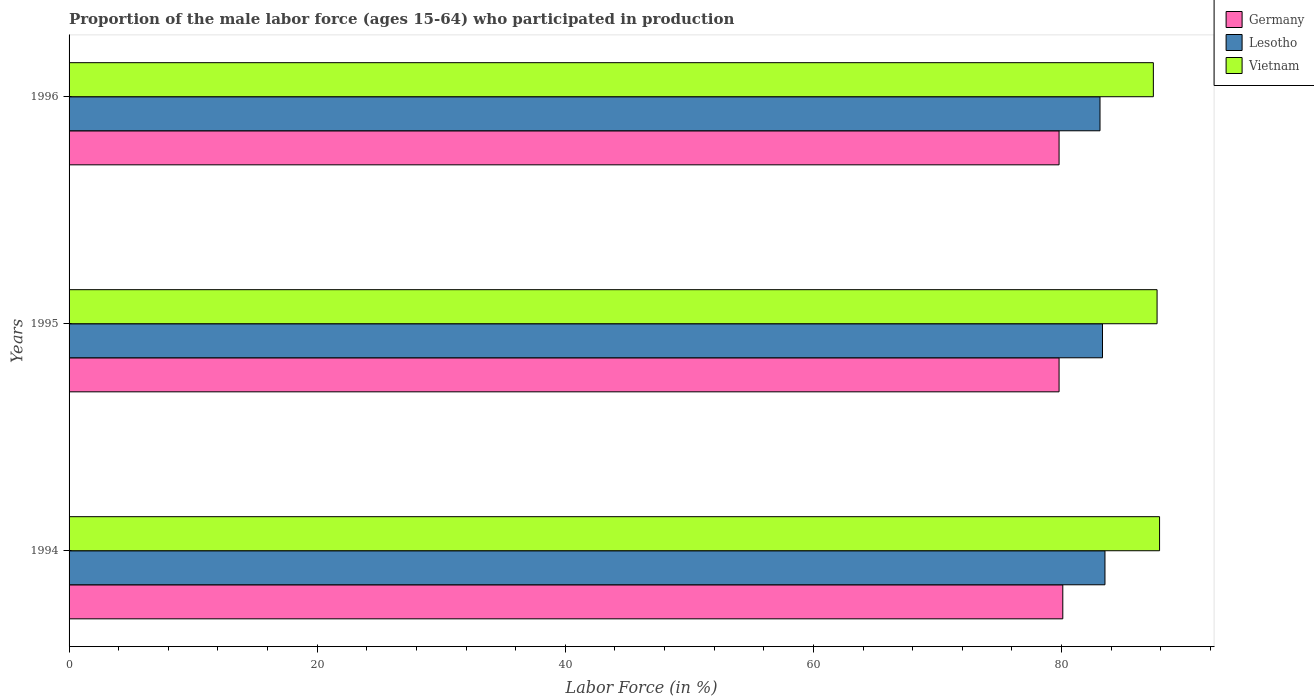How many different coloured bars are there?
Provide a succinct answer. 3. Are the number of bars per tick equal to the number of legend labels?
Provide a short and direct response. Yes. Are the number of bars on each tick of the Y-axis equal?
Ensure brevity in your answer.  Yes. How many bars are there on the 3rd tick from the top?
Your response must be concise. 3. How many bars are there on the 1st tick from the bottom?
Your answer should be very brief. 3. What is the label of the 3rd group of bars from the top?
Offer a terse response. 1994. What is the proportion of the male labor force who participated in production in Lesotho in 1994?
Give a very brief answer. 83.5. Across all years, what is the maximum proportion of the male labor force who participated in production in Vietnam?
Give a very brief answer. 87.9. Across all years, what is the minimum proportion of the male labor force who participated in production in Vietnam?
Provide a short and direct response. 87.4. In which year was the proportion of the male labor force who participated in production in Germany maximum?
Ensure brevity in your answer.  1994. In which year was the proportion of the male labor force who participated in production in Germany minimum?
Offer a terse response. 1995. What is the total proportion of the male labor force who participated in production in Germany in the graph?
Ensure brevity in your answer.  239.7. What is the difference between the proportion of the male labor force who participated in production in Vietnam in 1994 and that in 1995?
Your answer should be compact. 0.2. What is the difference between the proportion of the male labor force who participated in production in Germany in 1994 and the proportion of the male labor force who participated in production in Vietnam in 1995?
Offer a very short reply. -7.6. What is the average proportion of the male labor force who participated in production in Germany per year?
Ensure brevity in your answer.  79.9. In the year 1995, what is the difference between the proportion of the male labor force who participated in production in Germany and proportion of the male labor force who participated in production in Vietnam?
Offer a terse response. -7.9. In how many years, is the proportion of the male labor force who participated in production in Germany greater than 16 %?
Offer a terse response. 3. What is the ratio of the proportion of the male labor force who participated in production in Vietnam in 1994 to that in 1996?
Provide a short and direct response. 1.01. Is the proportion of the male labor force who participated in production in Vietnam in 1995 less than that in 1996?
Your answer should be very brief. No. Is the difference between the proportion of the male labor force who participated in production in Germany in 1995 and 1996 greater than the difference between the proportion of the male labor force who participated in production in Vietnam in 1995 and 1996?
Provide a succinct answer. No. What is the difference between the highest and the second highest proportion of the male labor force who participated in production in Germany?
Your answer should be compact. 0.3. What is the difference between the highest and the lowest proportion of the male labor force who participated in production in Lesotho?
Your answer should be very brief. 0.4. What does the 1st bar from the top in 1995 represents?
Keep it short and to the point. Vietnam. What does the 1st bar from the bottom in 1996 represents?
Provide a succinct answer. Germany. Are all the bars in the graph horizontal?
Give a very brief answer. Yes. Where does the legend appear in the graph?
Keep it short and to the point. Top right. What is the title of the graph?
Ensure brevity in your answer.  Proportion of the male labor force (ages 15-64) who participated in production. Does "Arab World" appear as one of the legend labels in the graph?
Keep it short and to the point. No. What is the label or title of the Y-axis?
Make the answer very short. Years. What is the Labor Force (in %) of Germany in 1994?
Offer a very short reply. 80.1. What is the Labor Force (in %) in Lesotho in 1994?
Your response must be concise. 83.5. What is the Labor Force (in %) in Vietnam in 1994?
Give a very brief answer. 87.9. What is the Labor Force (in %) in Germany in 1995?
Your answer should be compact. 79.8. What is the Labor Force (in %) in Lesotho in 1995?
Your answer should be very brief. 83.3. What is the Labor Force (in %) in Vietnam in 1995?
Offer a terse response. 87.7. What is the Labor Force (in %) of Germany in 1996?
Provide a short and direct response. 79.8. What is the Labor Force (in %) of Lesotho in 1996?
Give a very brief answer. 83.1. What is the Labor Force (in %) of Vietnam in 1996?
Give a very brief answer. 87.4. Across all years, what is the maximum Labor Force (in %) in Germany?
Make the answer very short. 80.1. Across all years, what is the maximum Labor Force (in %) of Lesotho?
Offer a terse response. 83.5. Across all years, what is the maximum Labor Force (in %) of Vietnam?
Your answer should be very brief. 87.9. Across all years, what is the minimum Labor Force (in %) of Germany?
Your answer should be compact. 79.8. Across all years, what is the minimum Labor Force (in %) of Lesotho?
Give a very brief answer. 83.1. Across all years, what is the minimum Labor Force (in %) of Vietnam?
Provide a short and direct response. 87.4. What is the total Labor Force (in %) of Germany in the graph?
Your response must be concise. 239.7. What is the total Labor Force (in %) of Lesotho in the graph?
Offer a very short reply. 249.9. What is the total Labor Force (in %) in Vietnam in the graph?
Provide a short and direct response. 263. What is the difference between the Labor Force (in %) of Germany in 1994 and that in 1995?
Keep it short and to the point. 0.3. What is the difference between the Labor Force (in %) in Lesotho in 1994 and that in 1995?
Offer a terse response. 0.2. What is the difference between the Labor Force (in %) in Vietnam in 1994 and that in 1995?
Give a very brief answer. 0.2. What is the difference between the Labor Force (in %) of Germany in 1994 and that in 1996?
Your answer should be compact. 0.3. What is the difference between the Labor Force (in %) in Lesotho in 1994 and that in 1996?
Provide a short and direct response. 0.4. What is the difference between the Labor Force (in %) in Lesotho in 1995 and that in 1996?
Keep it short and to the point. 0.2. What is the difference between the Labor Force (in %) in Germany in 1994 and the Labor Force (in %) in Vietnam in 1995?
Your response must be concise. -7.6. What is the difference between the Labor Force (in %) of Lesotho in 1994 and the Labor Force (in %) of Vietnam in 1995?
Ensure brevity in your answer.  -4.2. What is the difference between the Labor Force (in %) in Germany in 1994 and the Labor Force (in %) in Lesotho in 1996?
Make the answer very short. -3. What is the difference between the Labor Force (in %) of Germany in 1995 and the Labor Force (in %) of Vietnam in 1996?
Give a very brief answer. -7.6. What is the difference between the Labor Force (in %) in Lesotho in 1995 and the Labor Force (in %) in Vietnam in 1996?
Your answer should be compact. -4.1. What is the average Labor Force (in %) in Germany per year?
Ensure brevity in your answer.  79.9. What is the average Labor Force (in %) of Lesotho per year?
Your response must be concise. 83.3. What is the average Labor Force (in %) of Vietnam per year?
Give a very brief answer. 87.67. In the year 1994, what is the difference between the Labor Force (in %) of Lesotho and Labor Force (in %) of Vietnam?
Your answer should be compact. -4.4. In the year 1995, what is the difference between the Labor Force (in %) in Germany and Labor Force (in %) in Vietnam?
Give a very brief answer. -7.9. In the year 1995, what is the difference between the Labor Force (in %) in Lesotho and Labor Force (in %) in Vietnam?
Offer a very short reply. -4.4. In the year 1996, what is the difference between the Labor Force (in %) in Germany and Labor Force (in %) in Lesotho?
Provide a short and direct response. -3.3. What is the ratio of the Labor Force (in %) of Lesotho in 1994 to that in 1995?
Offer a terse response. 1. What is the ratio of the Labor Force (in %) in Germany in 1994 to that in 1996?
Keep it short and to the point. 1. What is the ratio of the Labor Force (in %) in Lesotho in 1994 to that in 1996?
Make the answer very short. 1. What is the ratio of the Labor Force (in %) in Germany in 1995 to that in 1996?
Keep it short and to the point. 1. What is the ratio of the Labor Force (in %) in Lesotho in 1995 to that in 1996?
Your response must be concise. 1. What is the difference between the highest and the second highest Labor Force (in %) in Germany?
Your answer should be very brief. 0.3. What is the difference between the highest and the lowest Labor Force (in %) of Germany?
Make the answer very short. 0.3. What is the difference between the highest and the lowest Labor Force (in %) in Lesotho?
Provide a succinct answer. 0.4. What is the difference between the highest and the lowest Labor Force (in %) of Vietnam?
Your response must be concise. 0.5. 